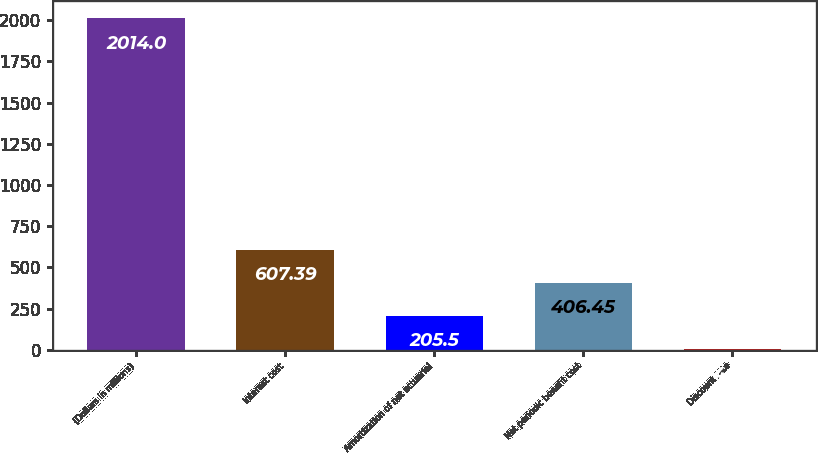<chart> <loc_0><loc_0><loc_500><loc_500><bar_chart><fcel>(Dollars in millions)<fcel>Interest cost<fcel>Amortization of net actuarial<fcel>Net periodic benefit cost<fcel>Discount rate<nl><fcel>2014<fcel>607.39<fcel>205.5<fcel>406.45<fcel>4.55<nl></chart> 